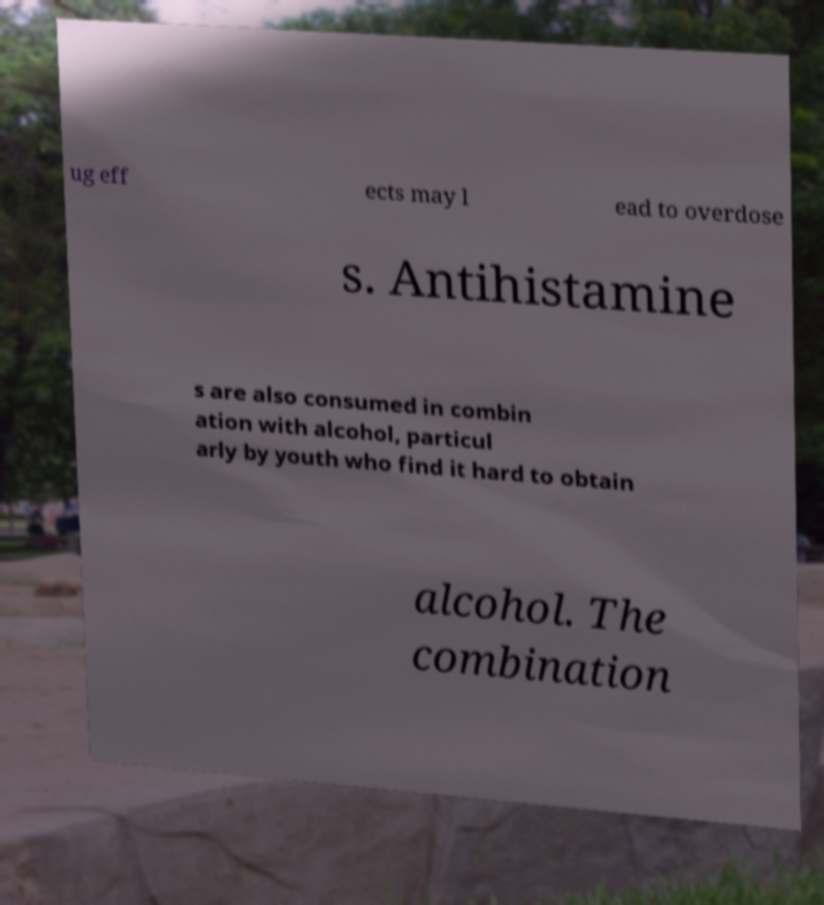What messages or text are displayed in this image? I need them in a readable, typed format. ug eff ects may l ead to overdose s. Antihistamine s are also consumed in combin ation with alcohol, particul arly by youth who find it hard to obtain alcohol. The combination 